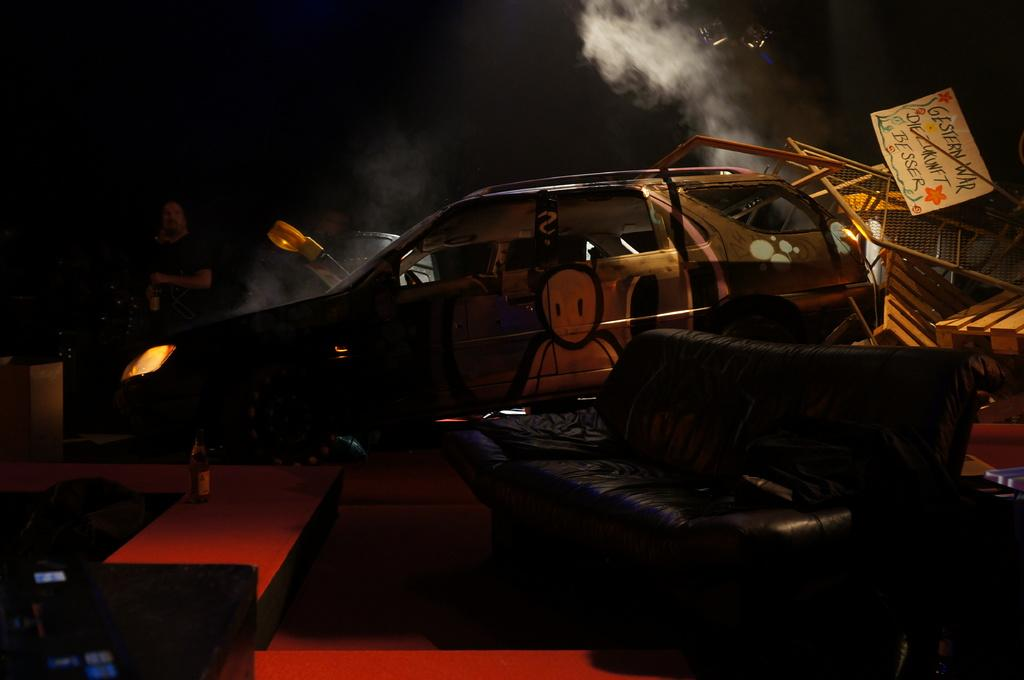What is the main subject of the image? The main subject of the image is a car. What can be observed about the car's headlights? The car's headlights are on. Can you describe the person in the image? There is a person standing behind the car. What type of seating is visible in front of the car? There is a bench and a sofa on the floor in front of the car. What type of bat is hanging from the car's rearview mirror in the image? There is no bat present in the image; it only features a car, a person, a bench, and a sofa. What type of authority figure can be seen in the image? There is no authority figure present in the image. 